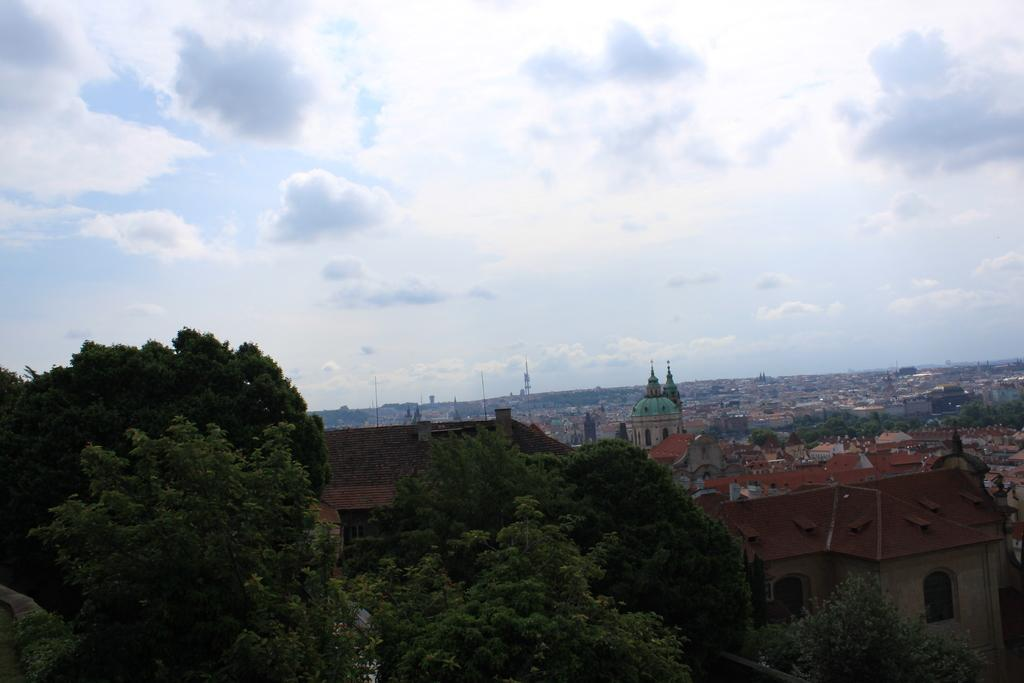What type of natural elements can be seen in the image? There are trees in the image. What type of man-made structures can be seen in the image? There are buildings and houses in the image. What is visible at the top of the image? The sky is visible at the top of the image. What is the weather like in the image? The sky appears to be sunny, suggesting a clear and bright day. What is the name of the van parked in front of the house in the image? There is no van present in the image; it only features trees, buildings, houses, and a sunny sky. 